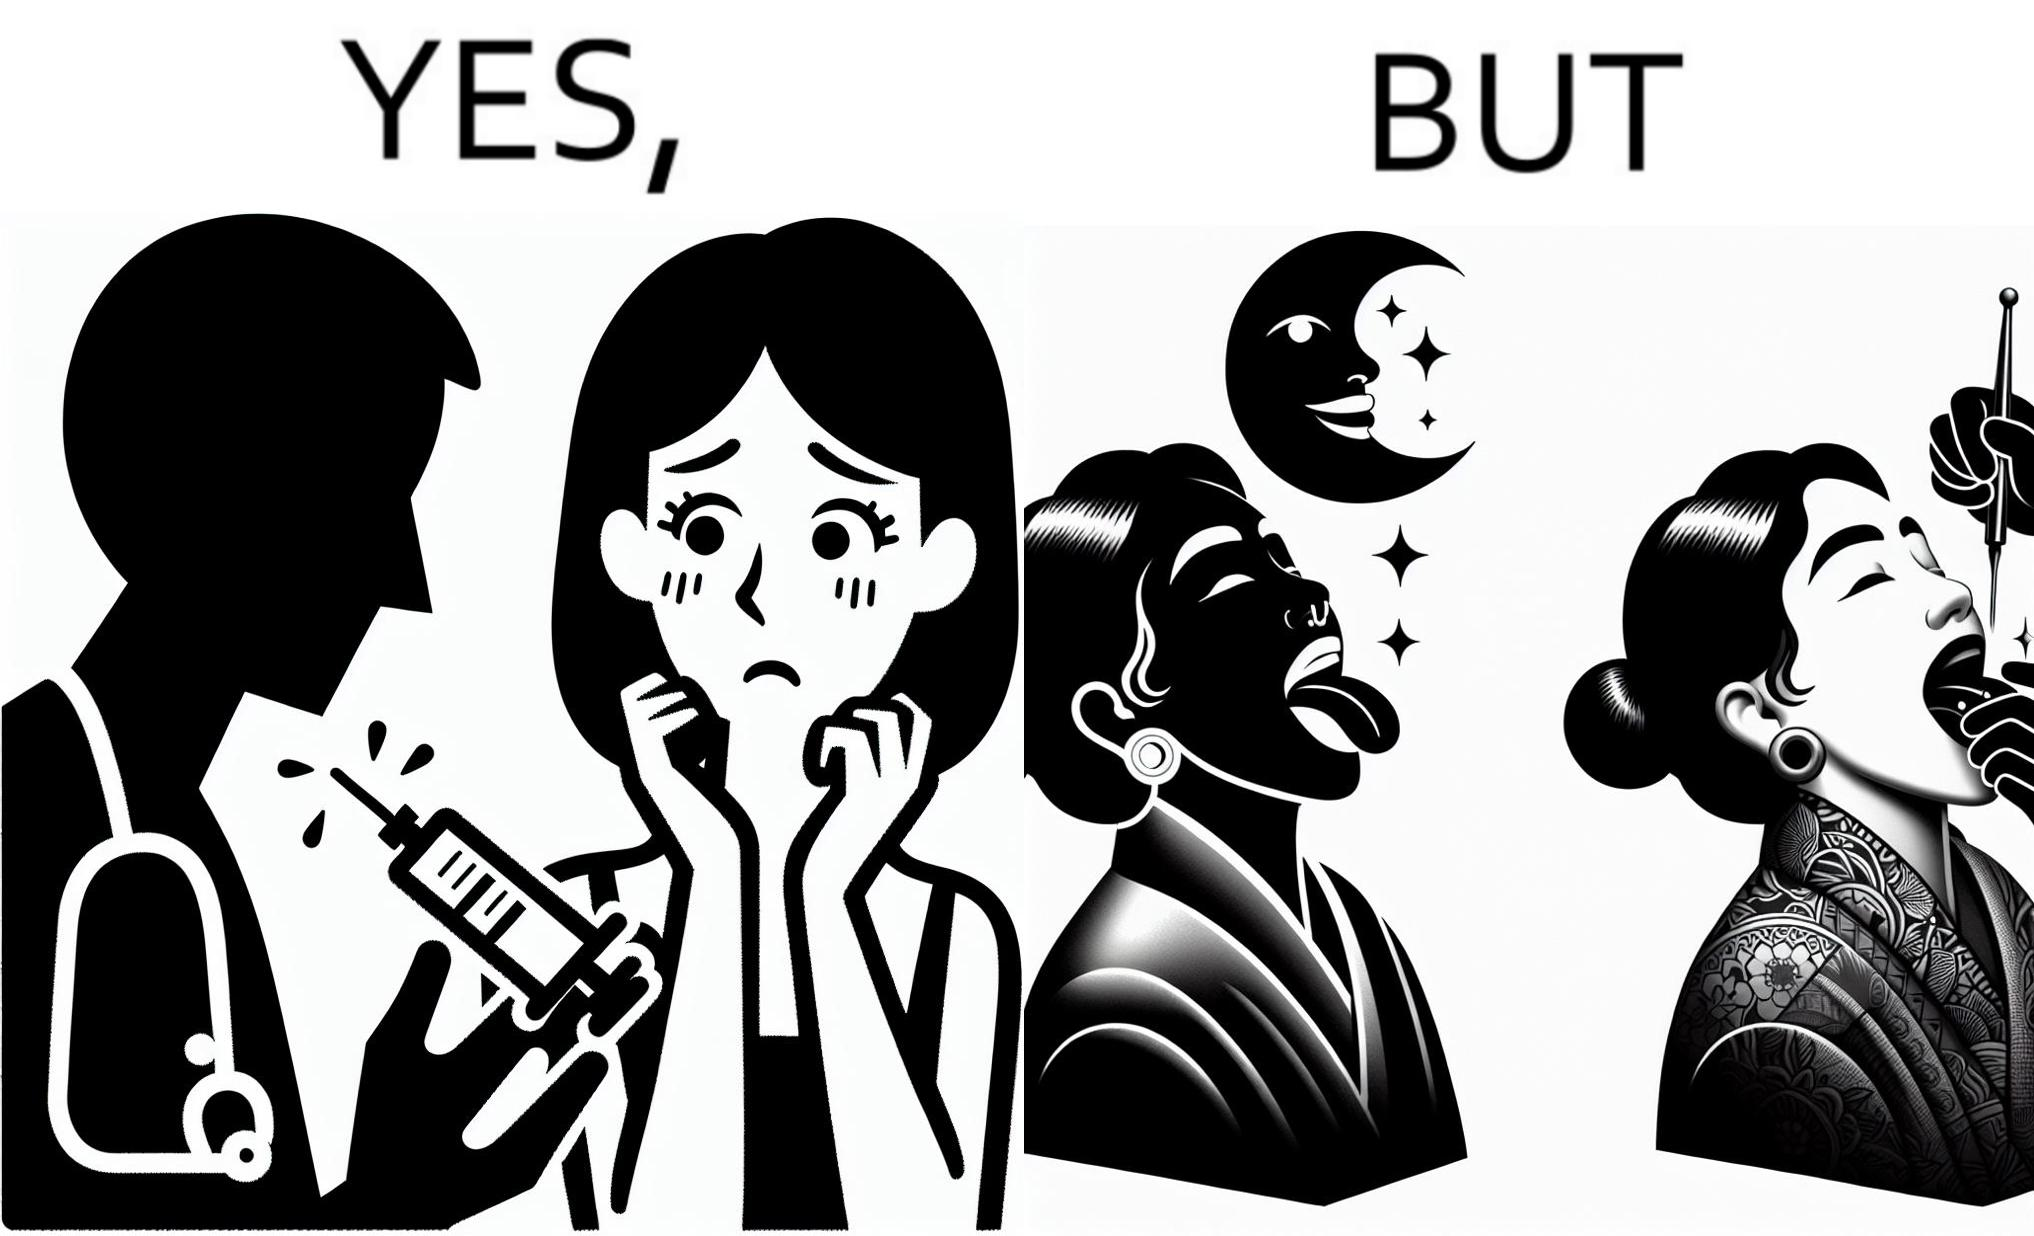Explain why this image is satirical. The image is funny becuase while the woman is scared of getting an injection which is for her benefit, she is not afraid of getting a piercing or a tattoo which are not going to help her in any way. 